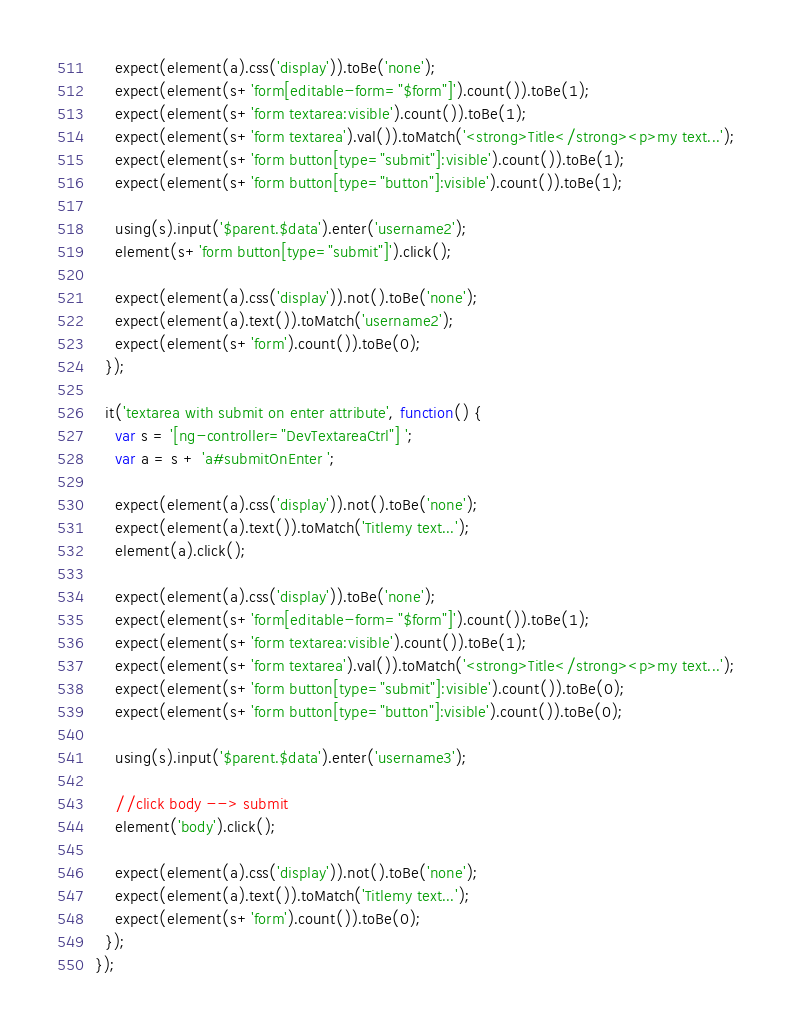Convert code to text. <code><loc_0><loc_0><loc_500><loc_500><_JavaScript_>
    expect(element(a).css('display')).toBe('none');
    expect(element(s+'form[editable-form="$form"]').count()).toBe(1);
    expect(element(s+'form textarea:visible').count()).toBe(1);
    expect(element(s+'form textarea').val()).toMatch('<strong>Title</strong><p>my text...');
    expect(element(s+'form button[type="submit"]:visible').count()).toBe(1);
    expect(element(s+'form button[type="button"]:visible').count()).toBe(1);

    using(s).input('$parent.$data').enter('username2');
    element(s+'form button[type="submit"]').click();

    expect(element(a).css('display')).not().toBe('none');
    expect(element(a).text()).toMatch('username2');
    expect(element(s+'form').count()).toBe(0);
  });

  it('textarea with submit on enter attribute', function() {
    var s = '[ng-controller="DevTextareaCtrl"] ';
    var a = s + 'a#submitOnEnter ';
    
    expect(element(a).css('display')).not().toBe('none');
    expect(element(a).text()).toMatch('Titlemy text...');
    element(a).click();

    expect(element(a).css('display')).toBe('none');
    expect(element(s+'form[editable-form="$form"]').count()).toBe(1);
    expect(element(s+'form textarea:visible').count()).toBe(1);
    expect(element(s+'form textarea').val()).toMatch('<strong>Title</strong><p>my text...');
    expect(element(s+'form button[type="submit"]:visible').count()).toBe(0);
    expect(element(s+'form button[type="button"]:visible').count()).toBe(0);
    
    using(s).input('$parent.$data').enter('username3');
    
    //click body --> submit
    element('body').click();

    expect(element(a).css('display')).not().toBe('none');
    expect(element(a).text()).toMatch('Titlemy text...');
    expect(element(s+'form').count()).toBe(0);
  });
});</code> 